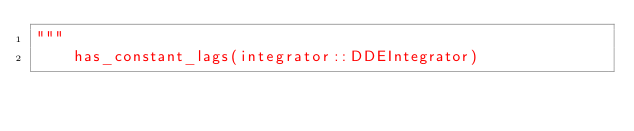Convert code to text. <code><loc_0><loc_0><loc_500><loc_500><_Julia_>"""
    has_constant_lags(integrator::DDEIntegrator)
</code> 